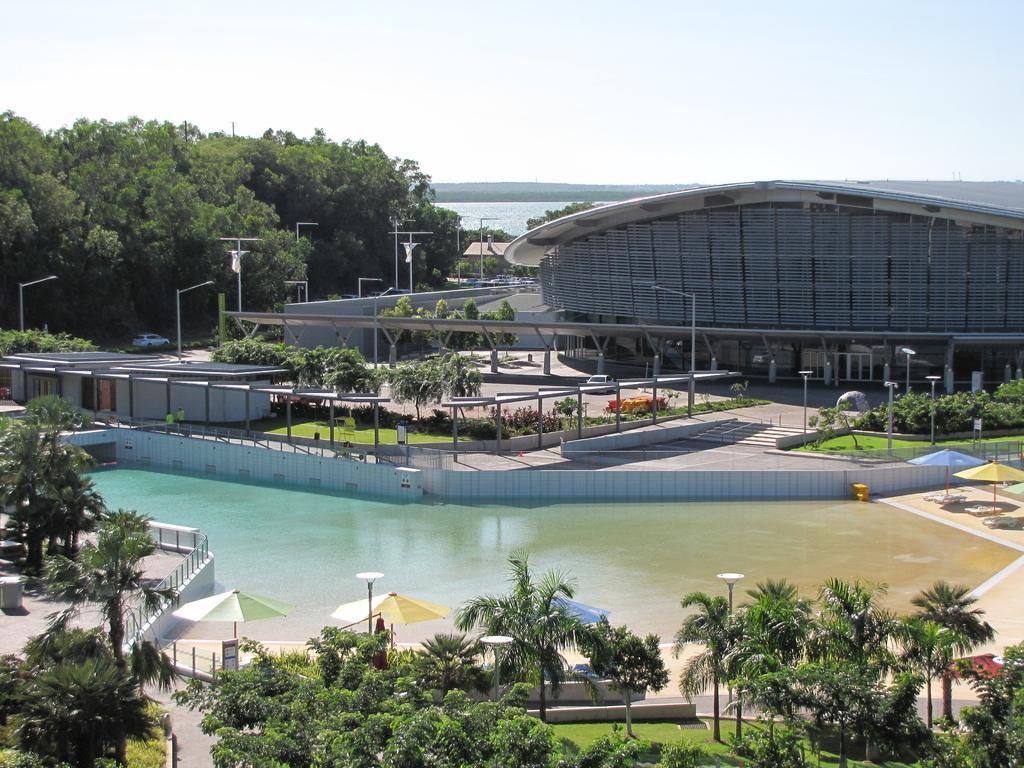Can you describe this image briefly? In the picture we can see a Ariel view of trees, plants, grass surface and water and around it we can see a wall and behind it we can see some path with some poles and lights to it and behind it we can see a building shed with pillars and besides we can see trees and behind it we can see water and sky. 